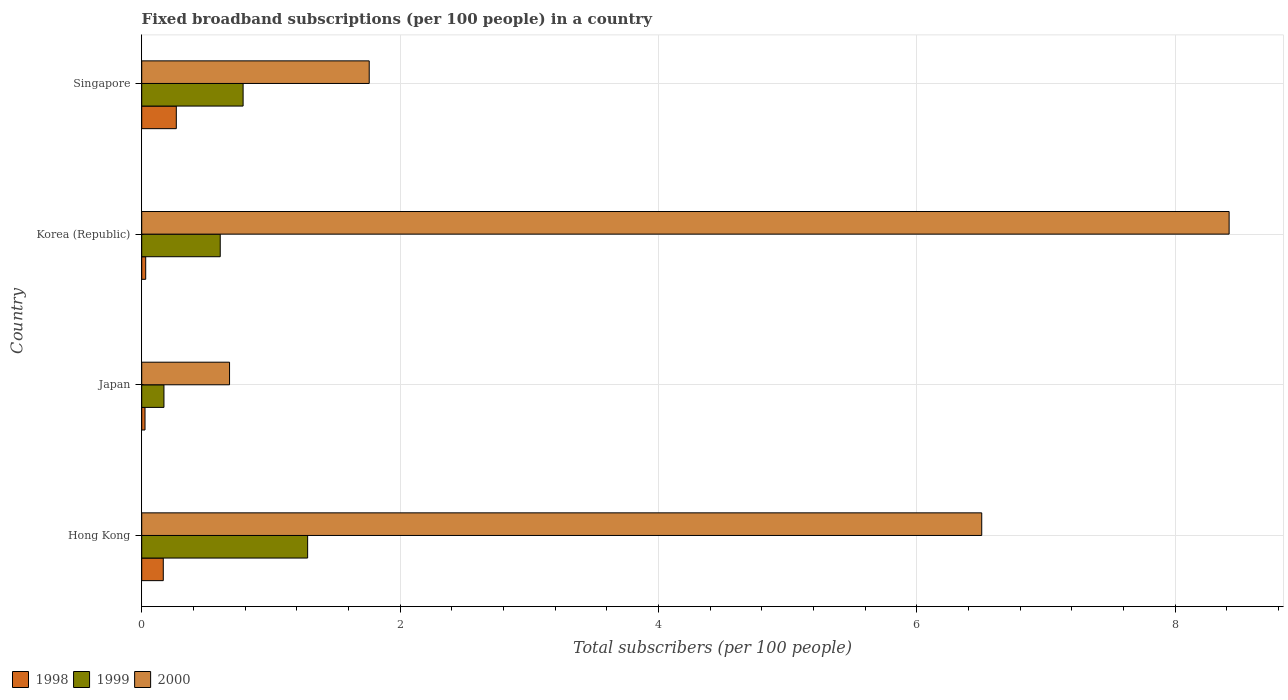How many different coloured bars are there?
Provide a succinct answer. 3. How many groups of bars are there?
Provide a short and direct response. 4. Are the number of bars per tick equal to the number of legend labels?
Your response must be concise. Yes. How many bars are there on the 1st tick from the bottom?
Ensure brevity in your answer.  3. What is the number of broadband subscriptions in 1999 in Singapore?
Keep it short and to the point. 0.78. Across all countries, what is the maximum number of broadband subscriptions in 1999?
Ensure brevity in your answer.  1.28. Across all countries, what is the minimum number of broadband subscriptions in 1998?
Make the answer very short. 0.03. In which country was the number of broadband subscriptions in 1999 maximum?
Offer a very short reply. Hong Kong. What is the total number of broadband subscriptions in 1998 in the graph?
Ensure brevity in your answer.  0.49. What is the difference between the number of broadband subscriptions in 1999 in Japan and that in Korea (Republic)?
Offer a very short reply. -0.44. What is the difference between the number of broadband subscriptions in 1998 in Hong Kong and the number of broadband subscriptions in 2000 in Korea (Republic)?
Provide a succinct answer. -8.25. What is the average number of broadband subscriptions in 1999 per country?
Provide a succinct answer. 0.71. What is the difference between the number of broadband subscriptions in 2000 and number of broadband subscriptions in 1998 in Singapore?
Keep it short and to the point. 1.49. In how many countries, is the number of broadband subscriptions in 1999 greater than 3.6 ?
Offer a very short reply. 0. What is the ratio of the number of broadband subscriptions in 1998 in Japan to that in Korea (Republic)?
Offer a terse response. 0.83. Is the number of broadband subscriptions in 1999 in Hong Kong less than that in Singapore?
Provide a succinct answer. No. Is the difference between the number of broadband subscriptions in 2000 in Korea (Republic) and Singapore greater than the difference between the number of broadband subscriptions in 1998 in Korea (Republic) and Singapore?
Your response must be concise. Yes. What is the difference between the highest and the second highest number of broadband subscriptions in 1999?
Your answer should be very brief. 0.5. What is the difference between the highest and the lowest number of broadband subscriptions in 2000?
Your answer should be compact. 7.74. In how many countries, is the number of broadband subscriptions in 1998 greater than the average number of broadband subscriptions in 1998 taken over all countries?
Offer a terse response. 2. Is the sum of the number of broadband subscriptions in 2000 in Japan and Singapore greater than the maximum number of broadband subscriptions in 1998 across all countries?
Make the answer very short. Yes. What does the 1st bar from the top in Korea (Republic) represents?
Your response must be concise. 2000. What does the 2nd bar from the bottom in Japan represents?
Provide a succinct answer. 1999. How many countries are there in the graph?
Your answer should be compact. 4. What is the difference between two consecutive major ticks on the X-axis?
Your response must be concise. 2. How many legend labels are there?
Give a very brief answer. 3. How are the legend labels stacked?
Ensure brevity in your answer.  Horizontal. What is the title of the graph?
Ensure brevity in your answer.  Fixed broadband subscriptions (per 100 people) in a country. What is the label or title of the X-axis?
Offer a very short reply. Total subscribers (per 100 people). What is the Total subscribers (per 100 people) in 1998 in Hong Kong?
Offer a very short reply. 0.17. What is the Total subscribers (per 100 people) of 1999 in Hong Kong?
Your response must be concise. 1.28. What is the Total subscribers (per 100 people) in 2000 in Hong Kong?
Your answer should be very brief. 6.5. What is the Total subscribers (per 100 people) of 1998 in Japan?
Provide a short and direct response. 0.03. What is the Total subscribers (per 100 people) of 1999 in Japan?
Ensure brevity in your answer.  0.17. What is the Total subscribers (per 100 people) of 2000 in Japan?
Your answer should be very brief. 0.68. What is the Total subscribers (per 100 people) in 1998 in Korea (Republic)?
Make the answer very short. 0.03. What is the Total subscribers (per 100 people) in 1999 in Korea (Republic)?
Provide a succinct answer. 0.61. What is the Total subscribers (per 100 people) in 2000 in Korea (Republic)?
Provide a short and direct response. 8.42. What is the Total subscribers (per 100 people) in 1998 in Singapore?
Offer a very short reply. 0.27. What is the Total subscribers (per 100 people) in 1999 in Singapore?
Your response must be concise. 0.78. What is the Total subscribers (per 100 people) in 2000 in Singapore?
Ensure brevity in your answer.  1.76. Across all countries, what is the maximum Total subscribers (per 100 people) of 1998?
Your response must be concise. 0.27. Across all countries, what is the maximum Total subscribers (per 100 people) of 1999?
Offer a terse response. 1.28. Across all countries, what is the maximum Total subscribers (per 100 people) of 2000?
Ensure brevity in your answer.  8.42. Across all countries, what is the minimum Total subscribers (per 100 people) in 1998?
Ensure brevity in your answer.  0.03. Across all countries, what is the minimum Total subscribers (per 100 people) in 1999?
Provide a succinct answer. 0.17. Across all countries, what is the minimum Total subscribers (per 100 people) in 2000?
Offer a very short reply. 0.68. What is the total Total subscribers (per 100 people) in 1998 in the graph?
Ensure brevity in your answer.  0.49. What is the total Total subscribers (per 100 people) of 1999 in the graph?
Provide a succinct answer. 2.85. What is the total Total subscribers (per 100 people) of 2000 in the graph?
Your response must be concise. 17.36. What is the difference between the Total subscribers (per 100 people) in 1998 in Hong Kong and that in Japan?
Offer a terse response. 0.14. What is the difference between the Total subscribers (per 100 people) in 1999 in Hong Kong and that in Japan?
Provide a succinct answer. 1.11. What is the difference between the Total subscribers (per 100 people) of 2000 in Hong Kong and that in Japan?
Ensure brevity in your answer.  5.82. What is the difference between the Total subscribers (per 100 people) in 1998 in Hong Kong and that in Korea (Republic)?
Your answer should be compact. 0.14. What is the difference between the Total subscribers (per 100 people) of 1999 in Hong Kong and that in Korea (Republic)?
Your response must be concise. 0.68. What is the difference between the Total subscribers (per 100 people) of 2000 in Hong Kong and that in Korea (Republic)?
Your answer should be very brief. -1.91. What is the difference between the Total subscribers (per 100 people) of 1998 in Hong Kong and that in Singapore?
Ensure brevity in your answer.  -0.1. What is the difference between the Total subscribers (per 100 people) of 1999 in Hong Kong and that in Singapore?
Ensure brevity in your answer.  0.5. What is the difference between the Total subscribers (per 100 people) in 2000 in Hong Kong and that in Singapore?
Your answer should be very brief. 4.74. What is the difference between the Total subscribers (per 100 people) of 1998 in Japan and that in Korea (Republic)?
Provide a succinct answer. -0.01. What is the difference between the Total subscribers (per 100 people) of 1999 in Japan and that in Korea (Republic)?
Make the answer very short. -0.44. What is the difference between the Total subscribers (per 100 people) in 2000 in Japan and that in Korea (Republic)?
Give a very brief answer. -7.74. What is the difference between the Total subscribers (per 100 people) of 1998 in Japan and that in Singapore?
Provide a succinct answer. -0.24. What is the difference between the Total subscribers (per 100 people) in 1999 in Japan and that in Singapore?
Ensure brevity in your answer.  -0.61. What is the difference between the Total subscribers (per 100 people) of 2000 in Japan and that in Singapore?
Offer a very short reply. -1.08. What is the difference between the Total subscribers (per 100 people) in 1998 in Korea (Republic) and that in Singapore?
Provide a short and direct response. -0.24. What is the difference between the Total subscribers (per 100 people) in 1999 in Korea (Republic) and that in Singapore?
Your answer should be very brief. -0.18. What is the difference between the Total subscribers (per 100 people) in 2000 in Korea (Republic) and that in Singapore?
Offer a terse response. 6.66. What is the difference between the Total subscribers (per 100 people) of 1998 in Hong Kong and the Total subscribers (per 100 people) of 1999 in Japan?
Ensure brevity in your answer.  -0.01. What is the difference between the Total subscribers (per 100 people) of 1998 in Hong Kong and the Total subscribers (per 100 people) of 2000 in Japan?
Your response must be concise. -0.51. What is the difference between the Total subscribers (per 100 people) of 1999 in Hong Kong and the Total subscribers (per 100 people) of 2000 in Japan?
Offer a very short reply. 0.6. What is the difference between the Total subscribers (per 100 people) of 1998 in Hong Kong and the Total subscribers (per 100 people) of 1999 in Korea (Republic)?
Provide a succinct answer. -0.44. What is the difference between the Total subscribers (per 100 people) of 1998 in Hong Kong and the Total subscribers (per 100 people) of 2000 in Korea (Republic)?
Provide a short and direct response. -8.25. What is the difference between the Total subscribers (per 100 people) of 1999 in Hong Kong and the Total subscribers (per 100 people) of 2000 in Korea (Republic)?
Give a very brief answer. -7.13. What is the difference between the Total subscribers (per 100 people) in 1998 in Hong Kong and the Total subscribers (per 100 people) in 1999 in Singapore?
Keep it short and to the point. -0.62. What is the difference between the Total subscribers (per 100 people) of 1998 in Hong Kong and the Total subscribers (per 100 people) of 2000 in Singapore?
Offer a terse response. -1.59. What is the difference between the Total subscribers (per 100 people) in 1999 in Hong Kong and the Total subscribers (per 100 people) in 2000 in Singapore?
Make the answer very short. -0.48. What is the difference between the Total subscribers (per 100 people) of 1998 in Japan and the Total subscribers (per 100 people) of 1999 in Korea (Republic)?
Make the answer very short. -0.58. What is the difference between the Total subscribers (per 100 people) in 1998 in Japan and the Total subscribers (per 100 people) in 2000 in Korea (Republic)?
Offer a very short reply. -8.39. What is the difference between the Total subscribers (per 100 people) of 1999 in Japan and the Total subscribers (per 100 people) of 2000 in Korea (Republic)?
Your answer should be very brief. -8.25. What is the difference between the Total subscribers (per 100 people) in 1998 in Japan and the Total subscribers (per 100 people) in 1999 in Singapore?
Offer a terse response. -0.76. What is the difference between the Total subscribers (per 100 people) in 1998 in Japan and the Total subscribers (per 100 people) in 2000 in Singapore?
Your answer should be very brief. -1.74. What is the difference between the Total subscribers (per 100 people) of 1999 in Japan and the Total subscribers (per 100 people) of 2000 in Singapore?
Give a very brief answer. -1.59. What is the difference between the Total subscribers (per 100 people) in 1998 in Korea (Republic) and the Total subscribers (per 100 people) in 1999 in Singapore?
Ensure brevity in your answer.  -0.75. What is the difference between the Total subscribers (per 100 people) in 1998 in Korea (Republic) and the Total subscribers (per 100 people) in 2000 in Singapore?
Your answer should be compact. -1.73. What is the difference between the Total subscribers (per 100 people) in 1999 in Korea (Republic) and the Total subscribers (per 100 people) in 2000 in Singapore?
Your response must be concise. -1.15. What is the average Total subscribers (per 100 people) in 1998 per country?
Give a very brief answer. 0.12. What is the average Total subscribers (per 100 people) of 1999 per country?
Offer a terse response. 0.71. What is the average Total subscribers (per 100 people) of 2000 per country?
Offer a terse response. 4.34. What is the difference between the Total subscribers (per 100 people) of 1998 and Total subscribers (per 100 people) of 1999 in Hong Kong?
Keep it short and to the point. -1.12. What is the difference between the Total subscribers (per 100 people) of 1998 and Total subscribers (per 100 people) of 2000 in Hong Kong?
Your answer should be very brief. -6.34. What is the difference between the Total subscribers (per 100 people) in 1999 and Total subscribers (per 100 people) in 2000 in Hong Kong?
Offer a terse response. -5.22. What is the difference between the Total subscribers (per 100 people) in 1998 and Total subscribers (per 100 people) in 1999 in Japan?
Provide a short and direct response. -0.15. What is the difference between the Total subscribers (per 100 people) of 1998 and Total subscribers (per 100 people) of 2000 in Japan?
Provide a succinct answer. -0.65. What is the difference between the Total subscribers (per 100 people) in 1999 and Total subscribers (per 100 people) in 2000 in Japan?
Keep it short and to the point. -0.51. What is the difference between the Total subscribers (per 100 people) of 1998 and Total subscribers (per 100 people) of 1999 in Korea (Republic)?
Keep it short and to the point. -0.58. What is the difference between the Total subscribers (per 100 people) of 1998 and Total subscribers (per 100 people) of 2000 in Korea (Republic)?
Your answer should be very brief. -8.39. What is the difference between the Total subscribers (per 100 people) in 1999 and Total subscribers (per 100 people) in 2000 in Korea (Republic)?
Provide a short and direct response. -7.81. What is the difference between the Total subscribers (per 100 people) in 1998 and Total subscribers (per 100 people) in 1999 in Singapore?
Keep it short and to the point. -0.52. What is the difference between the Total subscribers (per 100 people) of 1998 and Total subscribers (per 100 people) of 2000 in Singapore?
Keep it short and to the point. -1.49. What is the difference between the Total subscribers (per 100 people) of 1999 and Total subscribers (per 100 people) of 2000 in Singapore?
Ensure brevity in your answer.  -0.98. What is the ratio of the Total subscribers (per 100 people) of 1998 in Hong Kong to that in Japan?
Your answer should be compact. 6.53. What is the ratio of the Total subscribers (per 100 people) in 1999 in Hong Kong to that in Japan?
Provide a succinct answer. 7.46. What is the ratio of the Total subscribers (per 100 people) in 2000 in Hong Kong to that in Japan?
Provide a short and direct response. 9.56. What is the ratio of the Total subscribers (per 100 people) of 1998 in Hong Kong to that in Korea (Republic)?
Give a very brief answer. 5.42. What is the ratio of the Total subscribers (per 100 people) of 1999 in Hong Kong to that in Korea (Republic)?
Make the answer very short. 2.11. What is the ratio of the Total subscribers (per 100 people) of 2000 in Hong Kong to that in Korea (Republic)?
Your answer should be very brief. 0.77. What is the ratio of the Total subscribers (per 100 people) of 1998 in Hong Kong to that in Singapore?
Your answer should be compact. 0.62. What is the ratio of the Total subscribers (per 100 people) in 1999 in Hong Kong to that in Singapore?
Provide a short and direct response. 1.64. What is the ratio of the Total subscribers (per 100 people) in 2000 in Hong Kong to that in Singapore?
Offer a very short reply. 3.69. What is the ratio of the Total subscribers (per 100 people) of 1998 in Japan to that in Korea (Republic)?
Ensure brevity in your answer.  0.83. What is the ratio of the Total subscribers (per 100 people) in 1999 in Japan to that in Korea (Republic)?
Keep it short and to the point. 0.28. What is the ratio of the Total subscribers (per 100 people) of 2000 in Japan to that in Korea (Republic)?
Make the answer very short. 0.08. What is the ratio of the Total subscribers (per 100 people) of 1998 in Japan to that in Singapore?
Offer a terse response. 0.1. What is the ratio of the Total subscribers (per 100 people) in 1999 in Japan to that in Singapore?
Keep it short and to the point. 0.22. What is the ratio of the Total subscribers (per 100 people) of 2000 in Japan to that in Singapore?
Give a very brief answer. 0.39. What is the ratio of the Total subscribers (per 100 people) in 1998 in Korea (Republic) to that in Singapore?
Keep it short and to the point. 0.12. What is the ratio of the Total subscribers (per 100 people) in 1999 in Korea (Republic) to that in Singapore?
Your answer should be very brief. 0.77. What is the ratio of the Total subscribers (per 100 people) in 2000 in Korea (Republic) to that in Singapore?
Your response must be concise. 4.78. What is the difference between the highest and the second highest Total subscribers (per 100 people) in 1998?
Offer a very short reply. 0.1. What is the difference between the highest and the second highest Total subscribers (per 100 people) of 1999?
Offer a terse response. 0.5. What is the difference between the highest and the second highest Total subscribers (per 100 people) of 2000?
Provide a succinct answer. 1.91. What is the difference between the highest and the lowest Total subscribers (per 100 people) in 1998?
Keep it short and to the point. 0.24. What is the difference between the highest and the lowest Total subscribers (per 100 people) in 1999?
Make the answer very short. 1.11. What is the difference between the highest and the lowest Total subscribers (per 100 people) of 2000?
Ensure brevity in your answer.  7.74. 